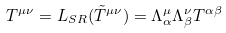Convert formula to latex. <formula><loc_0><loc_0><loc_500><loc_500>T ^ { \mu \nu } = L _ { S R } ( \tilde { T } ^ { \mu \nu } ) = \Lambda ^ { \mu } _ { \alpha } \Lambda ^ { \nu } _ { \beta } T ^ { \alpha \beta }</formula> 